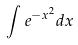Convert formula to latex. <formula><loc_0><loc_0><loc_500><loc_500>\int e ^ { - x ^ { 2 } } d x</formula> 